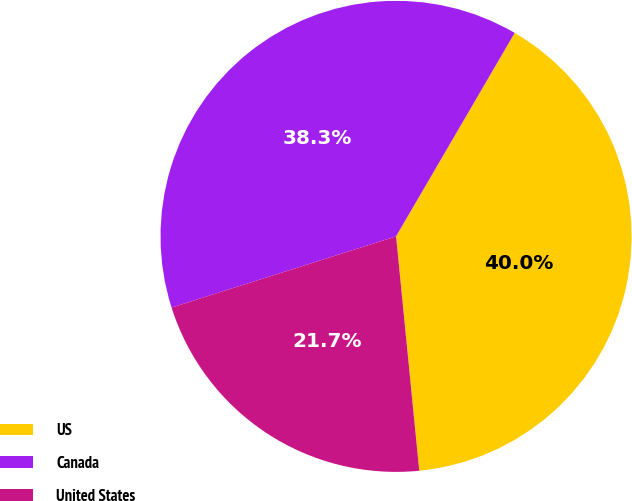<chart> <loc_0><loc_0><loc_500><loc_500><pie_chart><fcel>US<fcel>Canada<fcel>United States<nl><fcel>40.03%<fcel>38.29%<fcel>21.68%<nl></chart> 